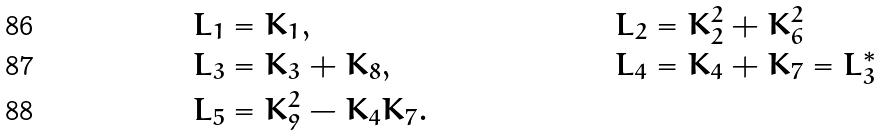Convert formula to latex. <formula><loc_0><loc_0><loc_500><loc_500>L _ { 1 } & = K _ { 1 } , & L _ { 2 } & = K _ { 2 } ^ { 2 } + K _ { 6 } ^ { 2 } \\ L _ { 3 } & = K _ { 3 } + K _ { 8 } , & L _ { 4 } & = K _ { 4 } + K _ { 7 } = L _ { 3 } ^ { * } \\ L _ { 5 } & = K _ { 9 } ^ { 2 } - K _ { 4 } K _ { 7 } .</formula> 